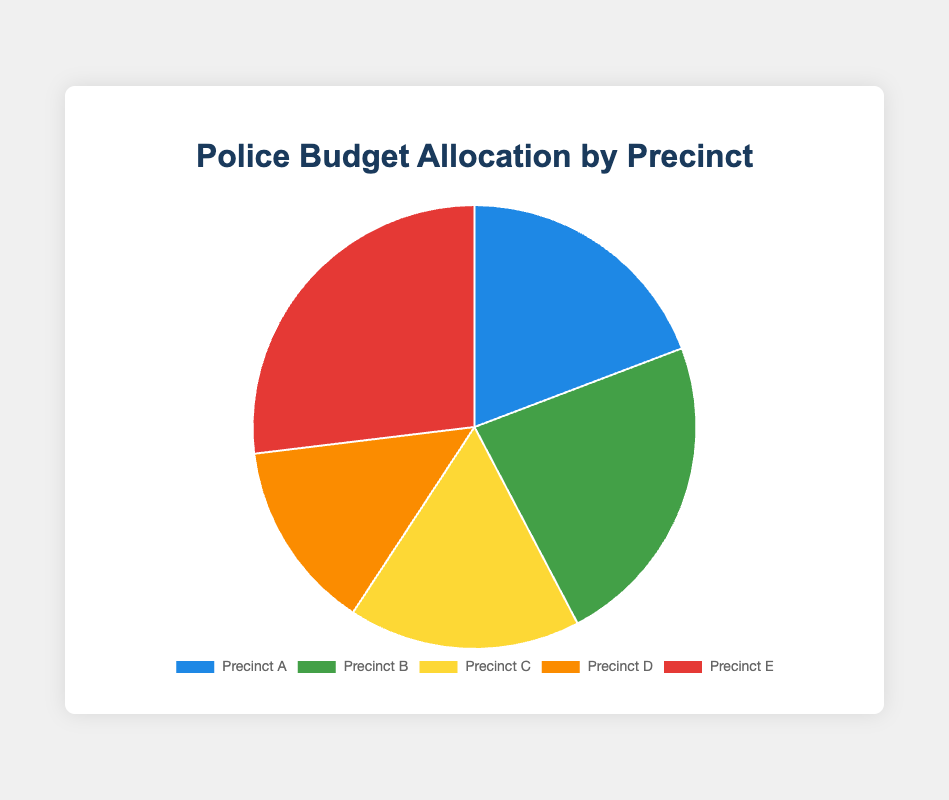What percentage of the total budget is allocated to Precinct E? First, sum up the total budget allocation for all precincts: (2500000 + 3000000 + 2200000 + 1800000 + 3500000) = 13000000. Then, divide the allocation of Precinct E by the total budget and multiply by 100: (3500000 / 13000000) * 100 ≈ 26.92%.
Answer: 26.92% Which precinct received the largest budget allocation? By examining the chart, we see that Precinct E has the largest slice, indicating it received the highest budget allocation of 3500000.
Answer: Precinct E How much greater is the budget allocation for Precinct B compared to Precinct D? Subtract the budget for Precinct D from the budget for Precinct B: 3000000 - 1800000 = 1200000.
Answer: 1200000 What is the combined budget allocation of Precinct A and Precinct C? Add the allocated funds for Precinct A and Precinct C: 2500000 + 2200000 = 4700000.
Answer: 4700000 Which precinct has the smallest budget allocation? By looking at the chart, the smallest slice corresponds to Precinct D, with an allocation of 1800000.
Answer: Precinct D If Precinct A's budget was increased by 10%, what would be its new allocation? First, calculate 10% of Precinct A's budget: 2500000 * 0.10 = 250000. Then, add this amount to the original budget: 2500000 + 250000 = 2750000.
Answer: 2750000 What is the difference between the budget allocations of Precinct C and Precinct E? Subtract the budget for Precinct C from the budget for Precinct E: 3500000 - 2200000 = 1300000.
Answer: 1300000 Which precincts have budget allocations greater than 2.5 million dollars? By examining the chart, the precincts that have allocations greater than 2500000 are Precinct B and Precinct E.
Answer: Precinct B, Precinct E How much would the total budget increase if Precinct D’s allocation was doubled? First, calculate the doubled allocation for Precinct D: 1800000 * 2 = 3600000. Then, add the increase to the original total budget: 13000000 + 1800000 = 14800000.
Answer: 14800000 